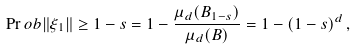Convert formula to latex. <formula><loc_0><loc_0><loc_500><loc_500>\Pr o b { \| \xi _ { 1 } \| \geq 1 - s } = 1 - \frac { \mu _ { d } ( B _ { 1 - s } ) } { \mu _ { d } ( B ) } = 1 - ( 1 - s ) ^ { d } \, ,</formula> 